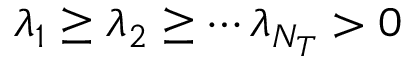<formula> <loc_0><loc_0><loc_500><loc_500>\lambda _ { 1 } \geq \lambda _ { 2 } \geq \cdots \lambda _ { N _ { T } } > 0</formula> 